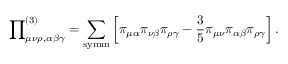<formula> <loc_0><loc_0><loc_500><loc_500>{ \prod } _ { \mu \nu \rho , \alpha \beta \gamma } ^ { ( 3 ) } = \sum _ { s y m m } \left [ \pi _ { \mu \alpha } \pi _ { \nu \beta } \pi _ { \rho \gamma } - \frac { 3 } { 5 } \pi _ { \mu \nu } \pi _ { \alpha \beta } \pi _ { \rho \gamma } \right ] .</formula> 